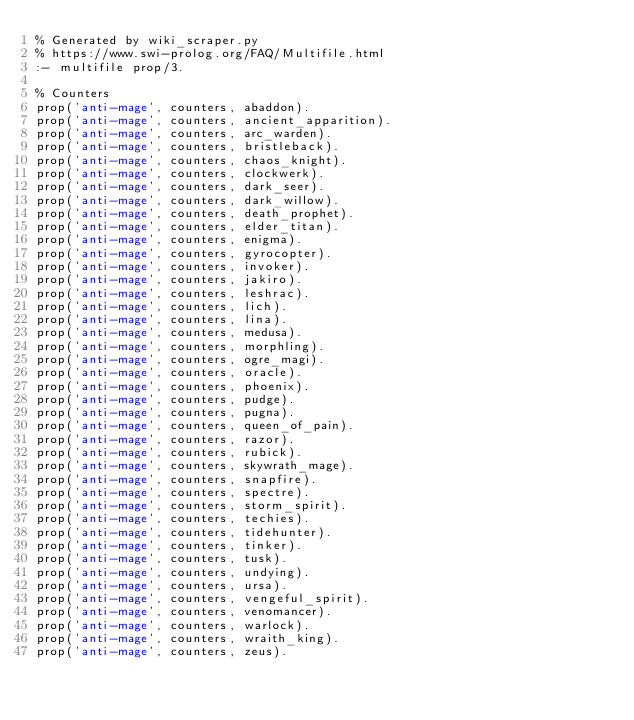Convert code to text. <code><loc_0><loc_0><loc_500><loc_500><_Perl_>% Generated by wiki_scraper.py
% https://www.swi-prolog.org/FAQ/Multifile.html
:- multifile prop/3.

% Counters
prop('anti-mage', counters, abaddon).
prop('anti-mage', counters, ancient_apparition).
prop('anti-mage', counters, arc_warden).
prop('anti-mage', counters, bristleback).
prop('anti-mage', counters, chaos_knight).
prop('anti-mage', counters, clockwerk).
prop('anti-mage', counters, dark_seer).
prop('anti-mage', counters, dark_willow).
prop('anti-mage', counters, death_prophet).
prop('anti-mage', counters, elder_titan).
prop('anti-mage', counters, enigma).
prop('anti-mage', counters, gyrocopter).
prop('anti-mage', counters, invoker).
prop('anti-mage', counters, jakiro).
prop('anti-mage', counters, leshrac).
prop('anti-mage', counters, lich).
prop('anti-mage', counters, lina).
prop('anti-mage', counters, medusa).
prop('anti-mage', counters, morphling).
prop('anti-mage', counters, ogre_magi).
prop('anti-mage', counters, oracle).
prop('anti-mage', counters, phoenix).
prop('anti-mage', counters, pudge).
prop('anti-mage', counters, pugna).
prop('anti-mage', counters, queen_of_pain).
prop('anti-mage', counters, razor).
prop('anti-mage', counters, rubick).
prop('anti-mage', counters, skywrath_mage).
prop('anti-mage', counters, snapfire).
prop('anti-mage', counters, spectre).
prop('anti-mage', counters, storm_spirit).
prop('anti-mage', counters, techies).
prop('anti-mage', counters, tidehunter).
prop('anti-mage', counters, tinker).
prop('anti-mage', counters, tusk).
prop('anti-mage', counters, undying).
prop('anti-mage', counters, ursa).
prop('anti-mage', counters, vengeful_spirit).
prop('anti-mage', counters, venomancer).
prop('anti-mage', counters, warlock).
prop('anti-mage', counters, wraith_king).
prop('anti-mage', counters, zeus).</code> 